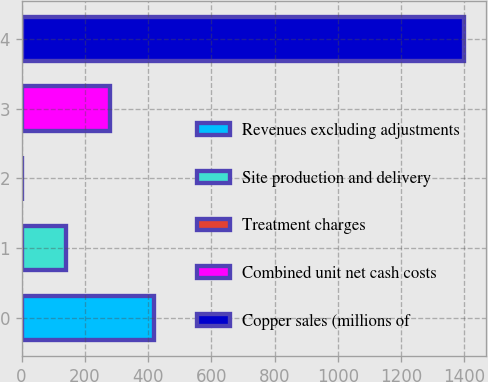<chart> <loc_0><loc_0><loc_500><loc_500><bar_chart><fcel>Revenues excluding adjustments<fcel>Site production and delivery<fcel>Treatment charges<fcel>Combined unit net cash costs<fcel>Copper sales (millions of<nl><fcel>419.84<fcel>140.08<fcel>0.2<fcel>279.96<fcel>1399<nl></chart> 